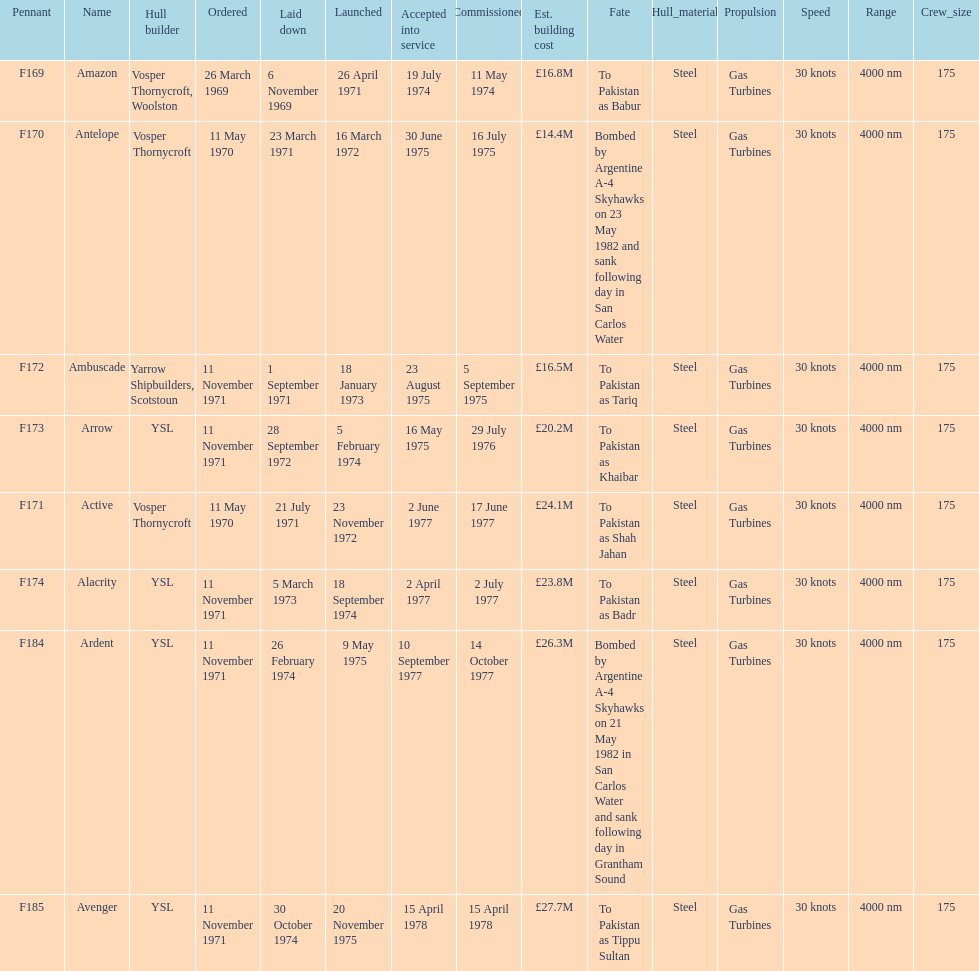Parse the table in full. {'header': ['Pennant', 'Name', 'Hull builder', 'Ordered', 'Laid down', 'Launched', 'Accepted into service', 'Commissioned', 'Est. building cost', 'Fate', 'Hull_material', 'Propulsion', 'Speed', 'Range', 'Crew_size'], 'rows': [['F169', 'Amazon', 'Vosper Thornycroft, Woolston', '26 March 1969', '6 November 1969', '26 April 1971', '19 July 1974', '11 May 1974', '£16.8M', 'To Pakistan as Babur', 'Steel', 'Gas Turbines', '30 knots', '4000 nm', '175'], ['F170', 'Antelope', 'Vosper Thornycroft', '11 May 1970', '23 March 1971', '16 March 1972', '30 June 1975', '16 July 1975', '£14.4M', 'Bombed by Argentine A-4 Skyhawks on 23 May 1982 and sank following day in San Carlos Water', 'Steel', 'Gas Turbines', '30 knots', '4000 nm', '175'], ['F172', 'Ambuscade', 'Yarrow Shipbuilders, Scotstoun', '11 November 1971', '1 September 1971', '18 January 1973', '23 August 1975', '5 September 1975', '£16.5M', 'To Pakistan as Tariq', 'Steel', 'Gas Turbines', '30 knots', '4000 nm', '175'], ['F173', 'Arrow', 'YSL', '11 November 1971', '28 September 1972', '5 February 1974', '16 May 1975', '29 July 1976', '£20.2M', 'To Pakistan as Khaibar', 'Steel', 'Gas Turbines', '30 knots', '4000 nm', '175'], ['F171', 'Active', 'Vosper Thornycroft', '11 May 1970', '21 July 1971', '23 November 1972', '2 June 1977', '17 June 1977', '£24.1M', 'To Pakistan as Shah Jahan', 'Steel', 'Gas Turbines', '30 knots', '4000 nm', '175'], ['F174', 'Alacrity', 'YSL', '11 November 1971', '5 March 1973', '18 September 1974', '2 April 1977', '2 July 1977', '£23.8M', 'To Pakistan as Badr', 'Steel', 'Gas Turbines', '30 knots', '4000 nm', '175'], ['F184', 'Ardent', 'YSL', '11 November 1971', '26 February 1974', '9 May 1975', '10 September 1977', '14 October 1977', '£26.3M', 'Bombed by Argentine A-4 Skyhawks on 21 May 1982 in San Carlos Water and sank following day in Grantham Sound', 'Steel', 'Gas Turbines', '30 knots', '4000 nm', '175'], ['F185', 'Avenger', 'YSL', '11 November 1971', '30 October 1974', '20 November 1975', '15 April 1978', '15 April 1978', '£27.7M', 'To Pakistan as Tippu Sultan', 'Steel', 'Gas Turbines', '30 knots', '4000 nm', '175']]} What is the subsequent pennant to f172? F173. 